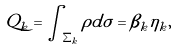Convert formula to latex. <formula><loc_0><loc_0><loc_500><loc_500>Q _ { k } = \int _ { \Sigma _ { k } } \rho d \sigma = \beta _ { k } \eta _ { k } ,</formula> 